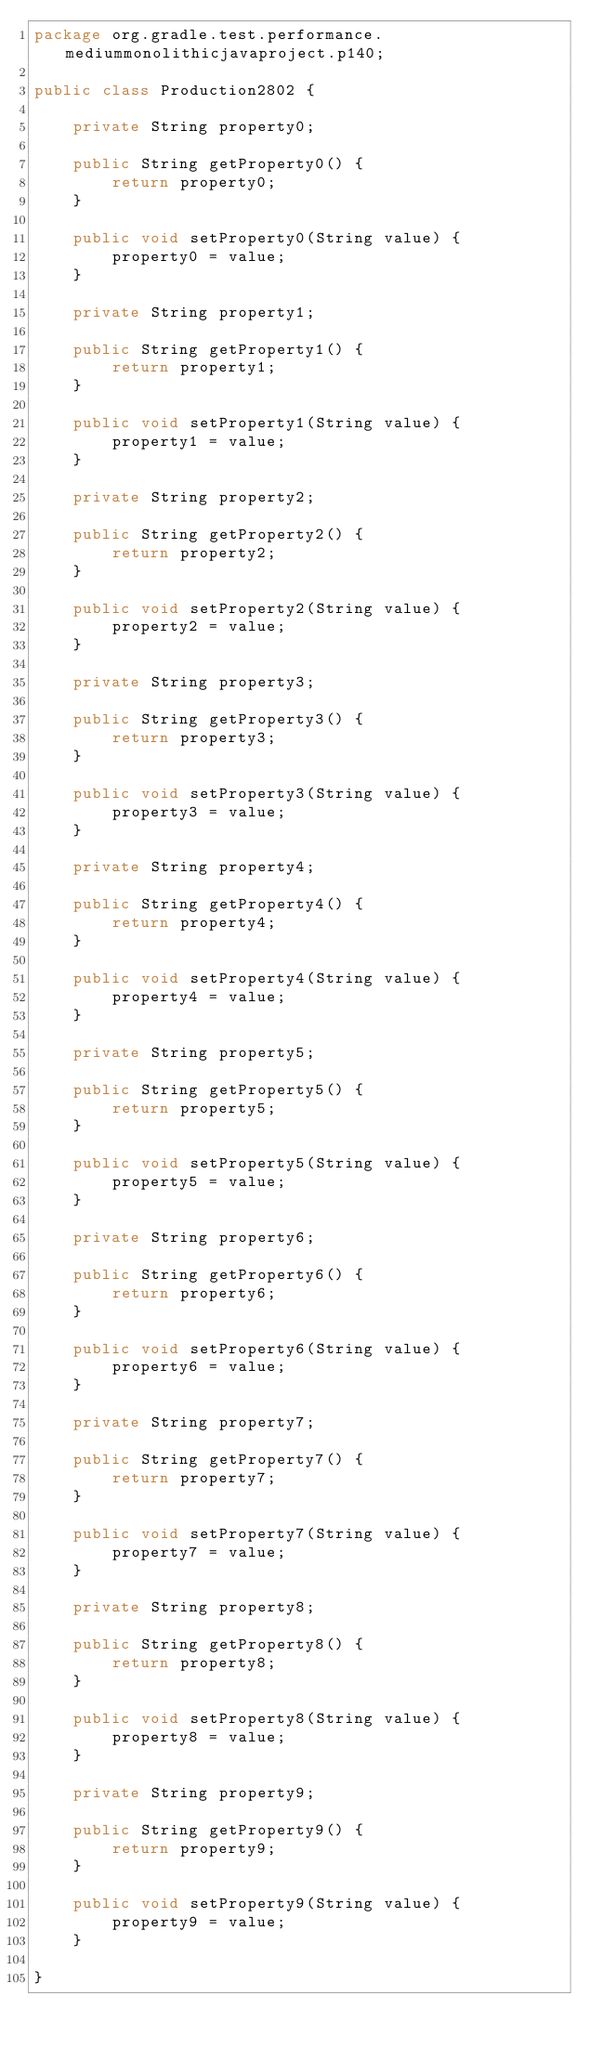Convert code to text. <code><loc_0><loc_0><loc_500><loc_500><_Java_>package org.gradle.test.performance.mediummonolithicjavaproject.p140;

public class Production2802 {        

    private String property0;

    public String getProperty0() {
        return property0;
    }

    public void setProperty0(String value) {
        property0 = value;
    }

    private String property1;

    public String getProperty1() {
        return property1;
    }

    public void setProperty1(String value) {
        property1 = value;
    }

    private String property2;

    public String getProperty2() {
        return property2;
    }

    public void setProperty2(String value) {
        property2 = value;
    }

    private String property3;

    public String getProperty3() {
        return property3;
    }

    public void setProperty3(String value) {
        property3 = value;
    }

    private String property4;

    public String getProperty4() {
        return property4;
    }

    public void setProperty4(String value) {
        property4 = value;
    }

    private String property5;

    public String getProperty5() {
        return property5;
    }

    public void setProperty5(String value) {
        property5 = value;
    }

    private String property6;

    public String getProperty6() {
        return property6;
    }

    public void setProperty6(String value) {
        property6 = value;
    }

    private String property7;

    public String getProperty7() {
        return property7;
    }

    public void setProperty7(String value) {
        property7 = value;
    }

    private String property8;

    public String getProperty8() {
        return property8;
    }

    public void setProperty8(String value) {
        property8 = value;
    }

    private String property9;

    public String getProperty9() {
        return property9;
    }

    public void setProperty9(String value) {
        property9 = value;
    }

}</code> 